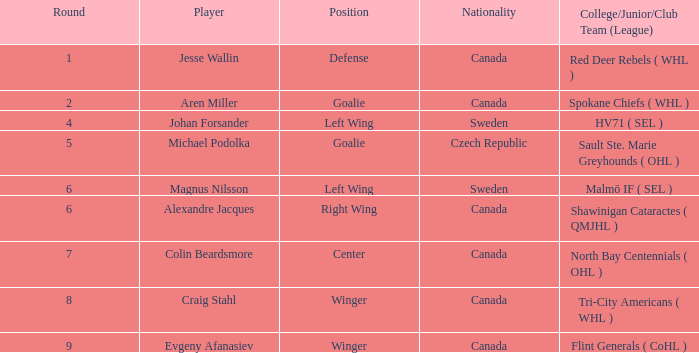What school/junior/club group (class) with a canadian origin occupies the role of a goalie? Spokane Chiefs ( WHL ). 